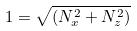<formula> <loc_0><loc_0><loc_500><loc_500>1 = \sqrt { ( N _ { x } ^ { 2 } + N _ { z } ^ { 2 } ) }</formula> 